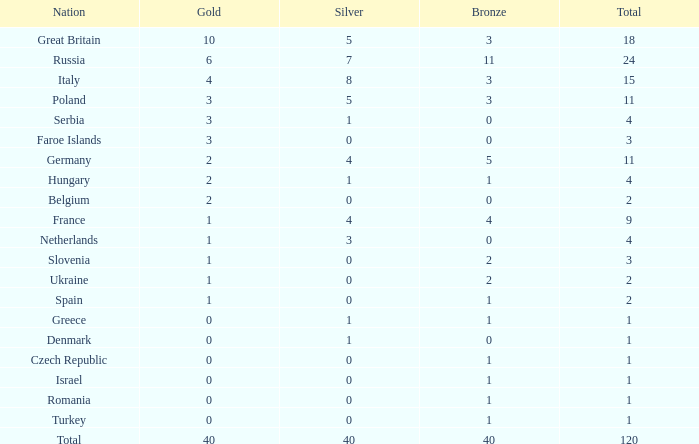What is the typical gold entry in turkey coupled with a bronze entry below 2 and a total surpassing 1? None. 